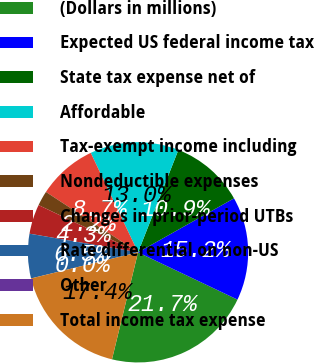Convert chart. <chart><loc_0><loc_0><loc_500><loc_500><pie_chart><fcel>(Dollars in millions)<fcel>Expected US federal income tax<fcel>State tax expense net of<fcel>Affordable<fcel>Tax-exempt income including<fcel>Nondeductible expenses<fcel>Changes in prior-period UTBs<fcel>Rate differential on non-US<fcel>Other<fcel>Total income tax expense<nl><fcel>21.74%<fcel>15.22%<fcel>10.87%<fcel>13.04%<fcel>8.7%<fcel>2.18%<fcel>4.35%<fcel>6.52%<fcel>0.0%<fcel>17.39%<nl></chart> 